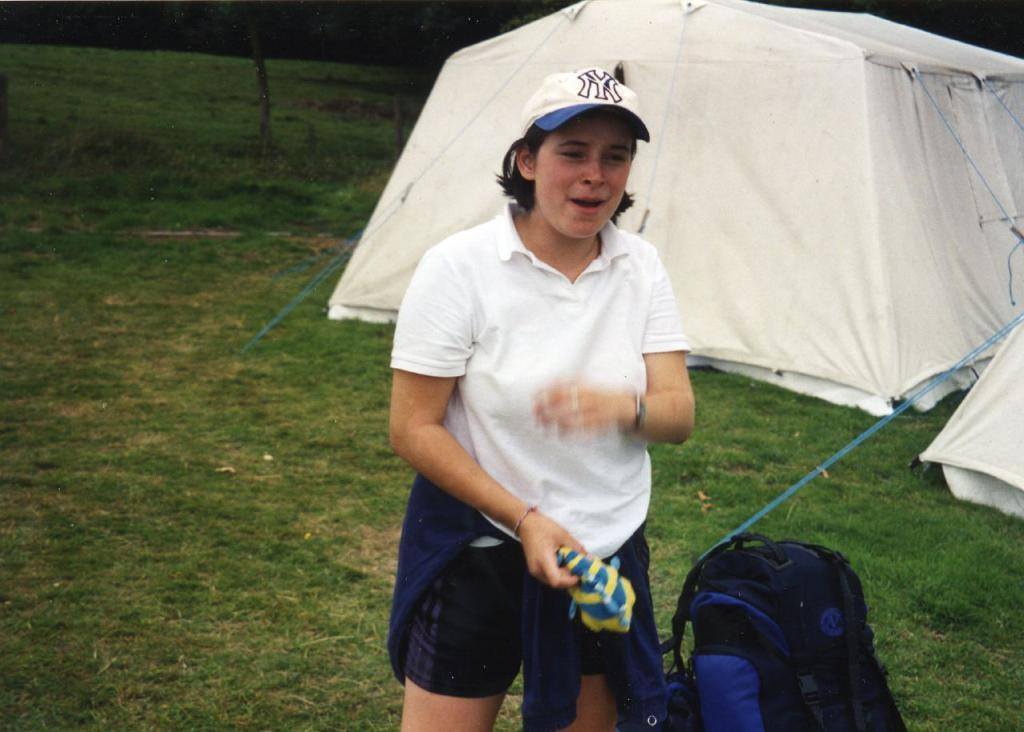What is the main subject of the image? There is a woman in the image. Where is the woman located? The woman is standing on the grass. What is the woman holding in the image? The woman is holding an object. What can be seen beside the woman? There is a bag beside the woman. What is visible in the background of the image? There are two camps and trees in the background of the image. What type of scarf is the woman wearing in the image? There is no scarf visible in the image; the woman is not wearing one. What division of the camps can be seen in the image? There is no division of the camps visible in the image; only two camps are present. 